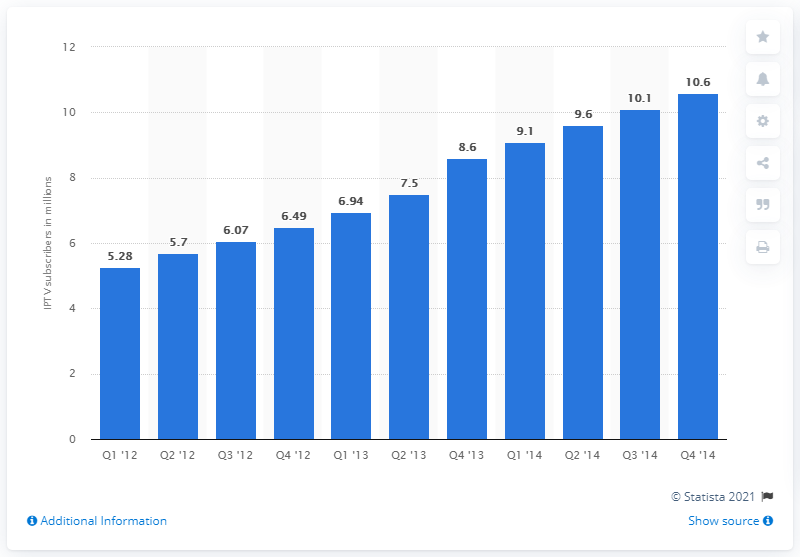Mention a couple of crucial points in this snapshot. As of the fourth quarter of 2013, there were approximately 8.6 million IPTV subscribers in South Korea. 